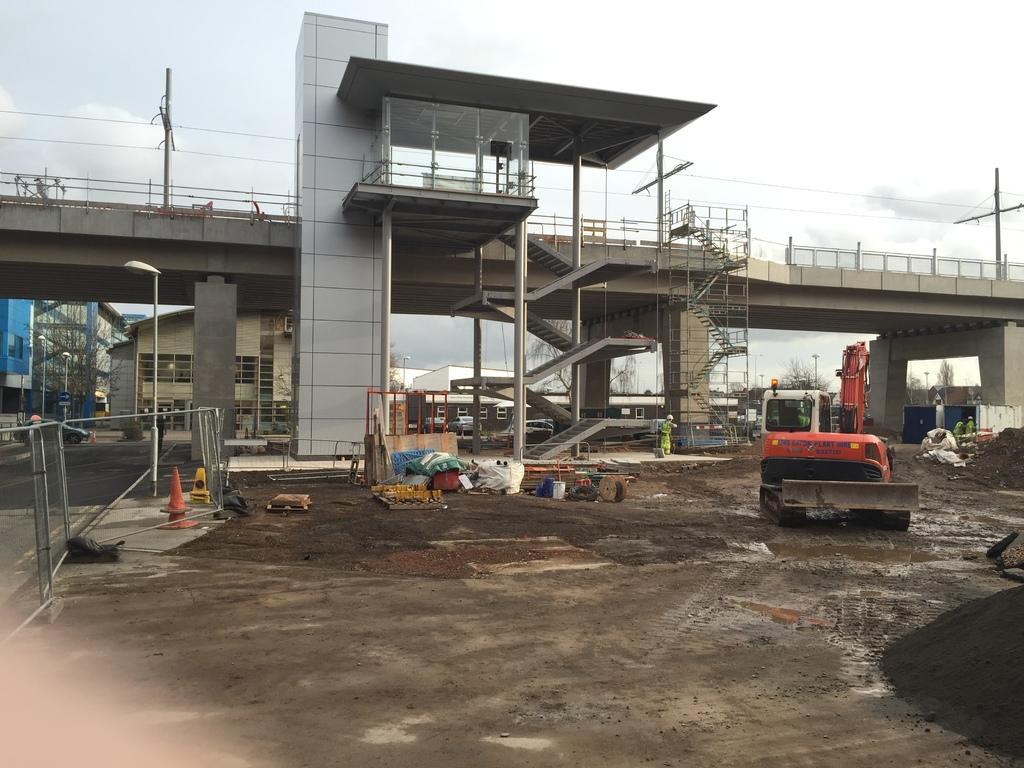How would you summarize this image in a sentence or two? here we see a bridge and a stairs to get on to the bridge and a crane and a street light and few buildings at the back. 